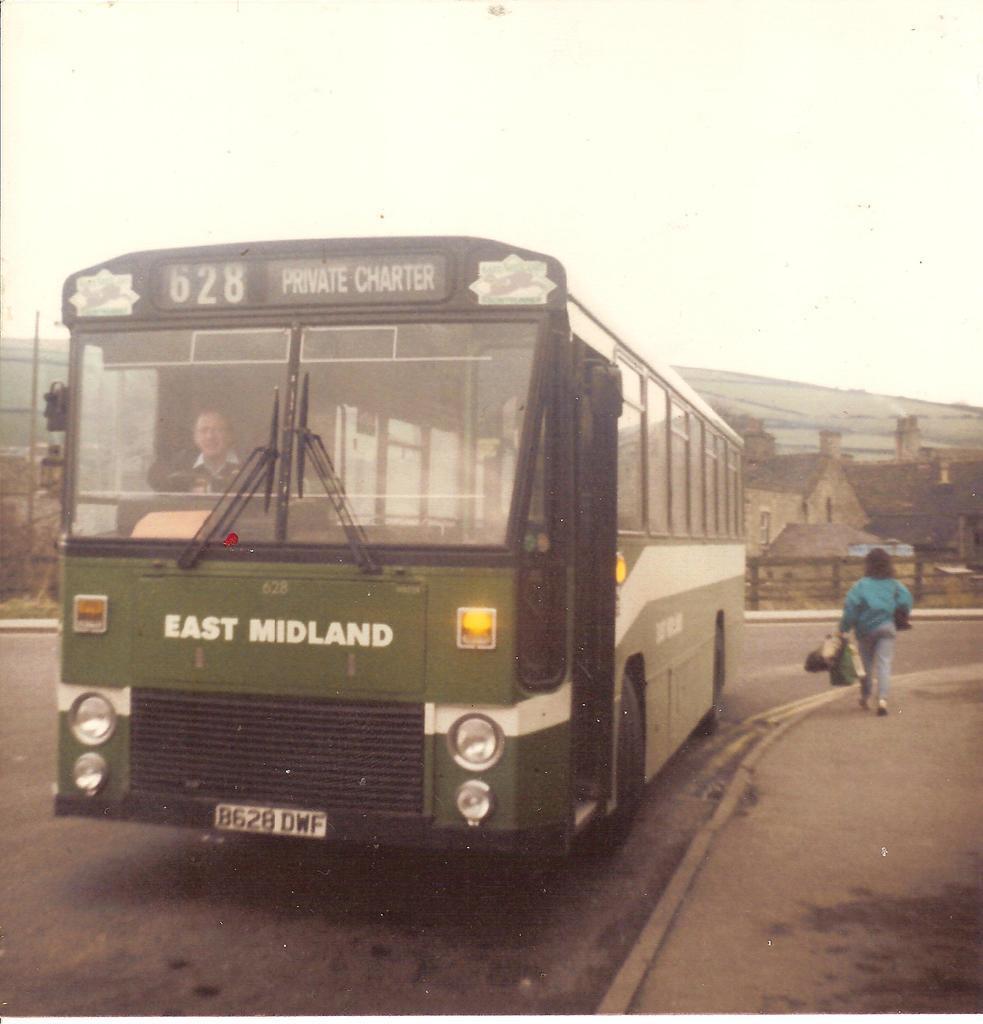Could you give a brief overview of what you see in this image? On the left side, there is a bus on the road. On the right side, there is a woman in a blue color t-shirt, holding bags and walking on a footpath. In the background, there are trees, buildings, a mountain and there are clouds in the sky. 